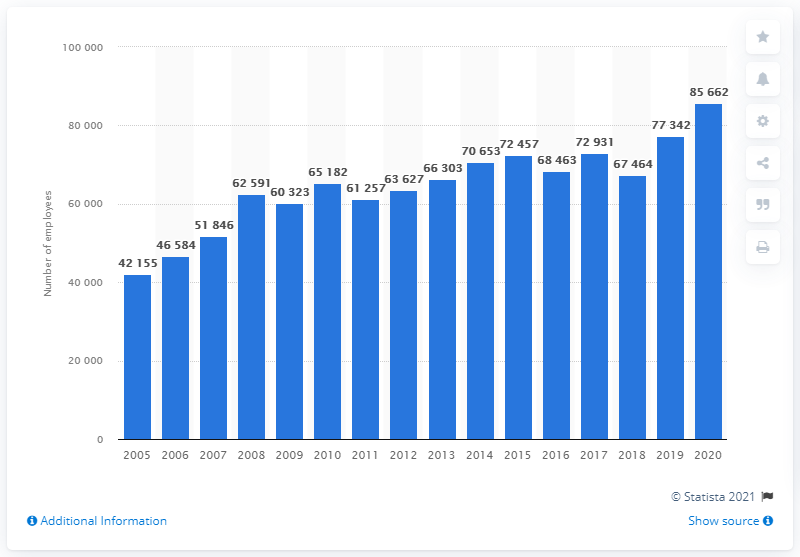Draw attention to some important aspects in this diagram. In 2020, Arvato AG had a total of 85,662 employees. 